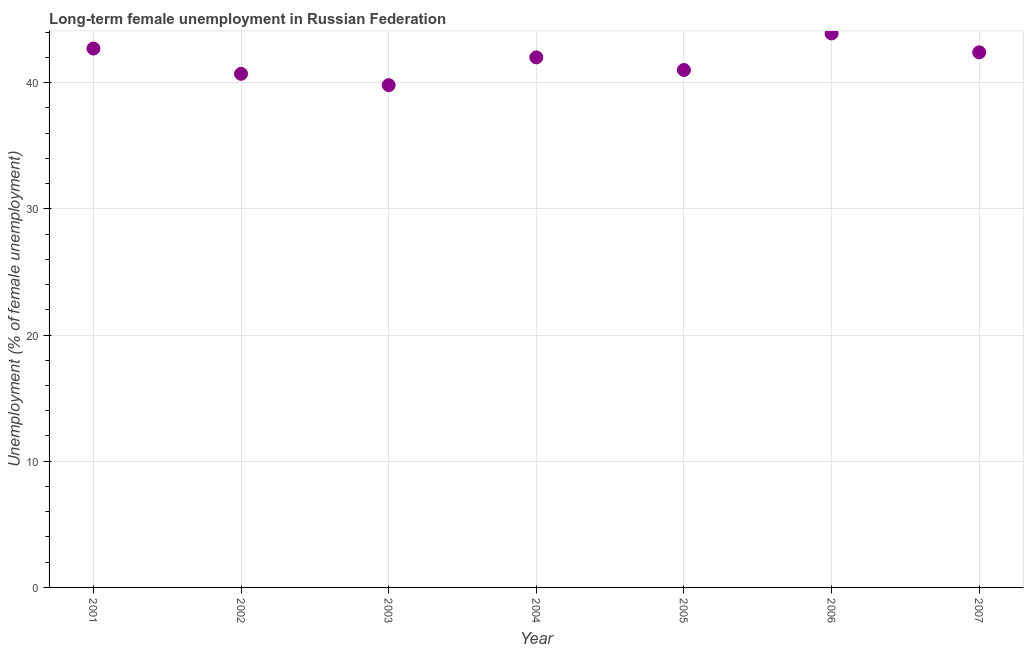Across all years, what is the maximum long-term female unemployment?
Provide a short and direct response. 43.9. Across all years, what is the minimum long-term female unemployment?
Provide a short and direct response. 39.8. What is the sum of the long-term female unemployment?
Your answer should be compact. 292.5. What is the difference between the long-term female unemployment in 2001 and 2002?
Your answer should be compact. 2. What is the average long-term female unemployment per year?
Provide a short and direct response. 41.79. What is the median long-term female unemployment?
Offer a very short reply. 42. What is the ratio of the long-term female unemployment in 2002 to that in 2005?
Your response must be concise. 0.99. Is the long-term female unemployment in 2003 less than that in 2007?
Ensure brevity in your answer.  Yes. Is the difference between the long-term female unemployment in 2004 and 2005 greater than the difference between any two years?
Give a very brief answer. No. What is the difference between the highest and the second highest long-term female unemployment?
Provide a short and direct response. 1.2. Is the sum of the long-term female unemployment in 2003 and 2007 greater than the maximum long-term female unemployment across all years?
Your answer should be compact. Yes. What is the difference between the highest and the lowest long-term female unemployment?
Give a very brief answer. 4.1. In how many years, is the long-term female unemployment greater than the average long-term female unemployment taken over all years?
Provide a short and direct response. 4. Does the long-term female unemployment monotonically increase over the years?
Your response must be concise. No. How many dotlines are there?
Make the answer very short. 1. How many years are there in the graph?
Provide a succinct answer. 7. Does the graph contain grids?
Ensure brevity in your answer.  Yes. What is the title of the graph?
Offer a very short reply. Long-term female unemployment in Russian Federation. What is the label or title of the Y-axis?
Offer a terse response. Unemployment (% of female unemployment). What is the Unemployment (% of female unemployment) in 2001?
Your answer should be very brief. 42.7. What is the Unemployment (% of female unemployment) in 2002?
Offer a very short reply. 40.7. What is the Unemployment (% of female unemployment) in 2003?
Keep it short and to the point. 39.8. What is the Unemployment (% of female unemployment) in 2004?
Keep it short and to the point. 42. What is the Unemployment (% of female unemployment) in 2006?
Your answer should be compact. 43.9. What is the Unemployment (% of female unemployment) in 2007?
Ensure brevity in your answer.  42.4. What is the difference between the Unemployment (% of female unemployment) in 2001 and 2004?
Offer a terse response. 0.7. What is the difference between the Unemployment (% of female unemployment) in 2001 and 2005?
Provide a succinct answer. 1.7. What is the difference between the Unemployment (% of female unemployment) in 2001 and 2007?
Give a very brief answer. 0.3. What is the difference between the Unemployment (% of female unemployment) in 2002 and 2004?
Make the answer very short. -1.3. What is the difference between the Unemployment (% of female unemployment) in 2002 and 2006?
Make the answer very short. -3.2. What is the difference between the Unemployment (% of female unemployment) in 2002 and 2007?
Give a very brief answer. -1.7. What is the difference between the Unemployment (% of female unemployment) in 2003 and 2005?
Give a very brief answer. -1.2. What is the difference between the Unemployment (% of female unemployment) in 2003 and 2006?
Keep it short and to the point. -4.1. What is the ratio of the Unemployment (% of female unemployment) in 2001 to that in 2002?
Your answer should be compact. 1.05. What is the ratio of the Unemployment (% of female unemployment) in 2001 to that in 2003?
Ensure brevity in your answer.  1.07. What is the ratio of the Unemployment (% of female unemployment) in 2001 to that in 2004?
Make the answer very short. 1.02. What is the ratio of the Unemployment (% of female unemployment) in 2001 to that in 2005?
Give a very brief answer. 1.04. What is the ratio of the Unemployment (% of female unemployment) in 2002 to that in 2005?
Give a very brief answer. 0.99. What is the ratio of the Unemployment (% of female unemployment) in 2002 to that in 2006?
Provide a succinct answer. 0.93. What is the ratio of the Unemployment (% of female unemployment) in 2002 to that in 2007?
Offer a terse response. 0.96. What is the ratio of the Unemployment (% of female unemployment) in 2003 to that in 2004?
Make the answer very short. 0.95. What is the ratio of the Unemployment (% of female unemployment) in 2003 to that in 2005?
Ensure brevity in your answer.  0.97. What is the ratio of the Unemployment (% of female unemployment) in 2003 to that in 2006?
Provide a succinct answer. 0.91. What is the ratio of the Unemployment (% of female unemployment) in 2003 to that in 2007?
Make the answer very short. 0.94. What is the ratio of the Unemployment (% of female unemployment) in 2005 to that in 2006?
Provide a short and direct response. 0.93. What is the ratio of the Unemployment (% of female unemployment) in 2005 to that in 2007?
Your answer should be compact. 0.97. What is the ratio of the Unemployment (% of female unemployment) in 2006 to that in 2007?
Offer a terse response. 1.03. 